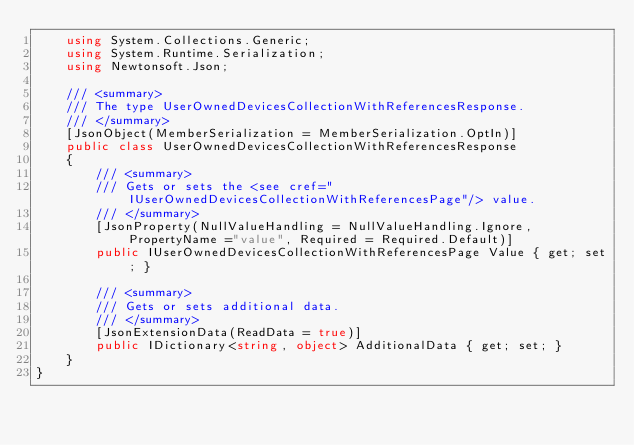<code> <loc_0><loc_0><loc_500><loc_500><_C#_>    using System.Collections.Generic;
    using System.Runtime.Serialization;
    using Newtonsoft.Json;

    /// <summary>
    /// The type UserOwnedDevicesCollectionWithReferencesResponse.
    /// </summary>
    [JsonObject(MemberSerialization = MemberSerialization.OptIn)]
    public class UserOwnedDevicesCollectionWithReferencesResponse
    {
        /// <summary>
        /// Gets or sets the <see cref="IUserOwnedDevicesCollectionWithReferencesPage"/> value.
        /// </summary>
		[JsonProperty(NullValueHandling = NullValueHandling.Ignore, PropertyName ="value", Required = Required.Default)]
        public IUserOwnedDevicesCollectionWithReferencesPage Value { get; set; }

        /// <summary>
        /// Gets or sets additional data.
        /// </summary>
        [JsonExtensionData(ReadData = true)]
        public IDictionary<string, object> AdditionalData { get; set; }
    }
}
</code> 